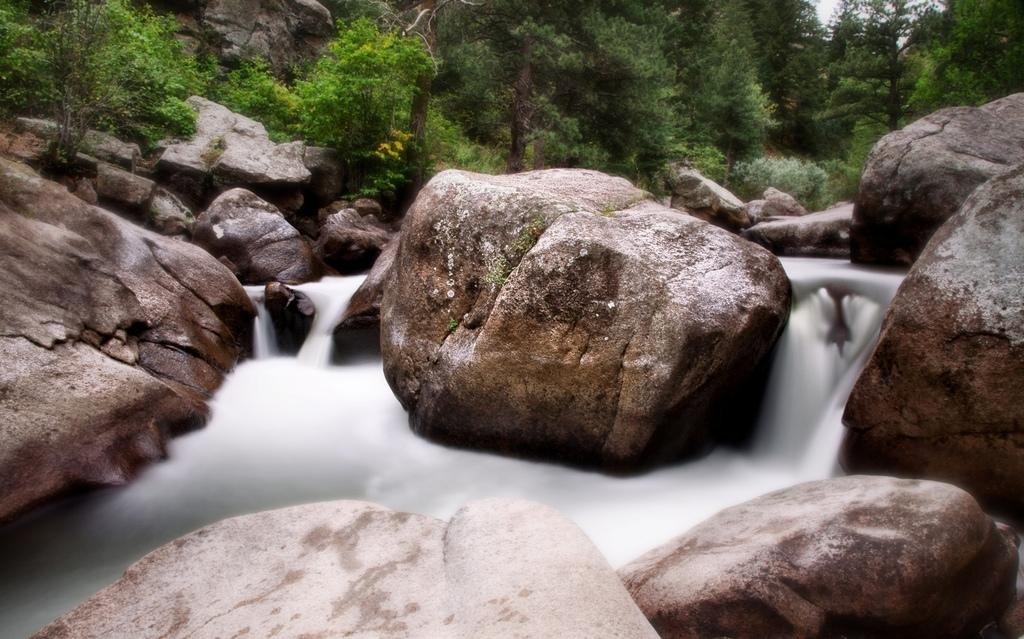What type of natural elements can be seen in the image? There are rocks and a water flow visible in the image. What can be observed in the background of the image? There are trees visible in the background of the image. What type of ticket is required to enter the home in the image? There is no home or ticket present in the image; it features rocks and a water flow with trees in the background. 